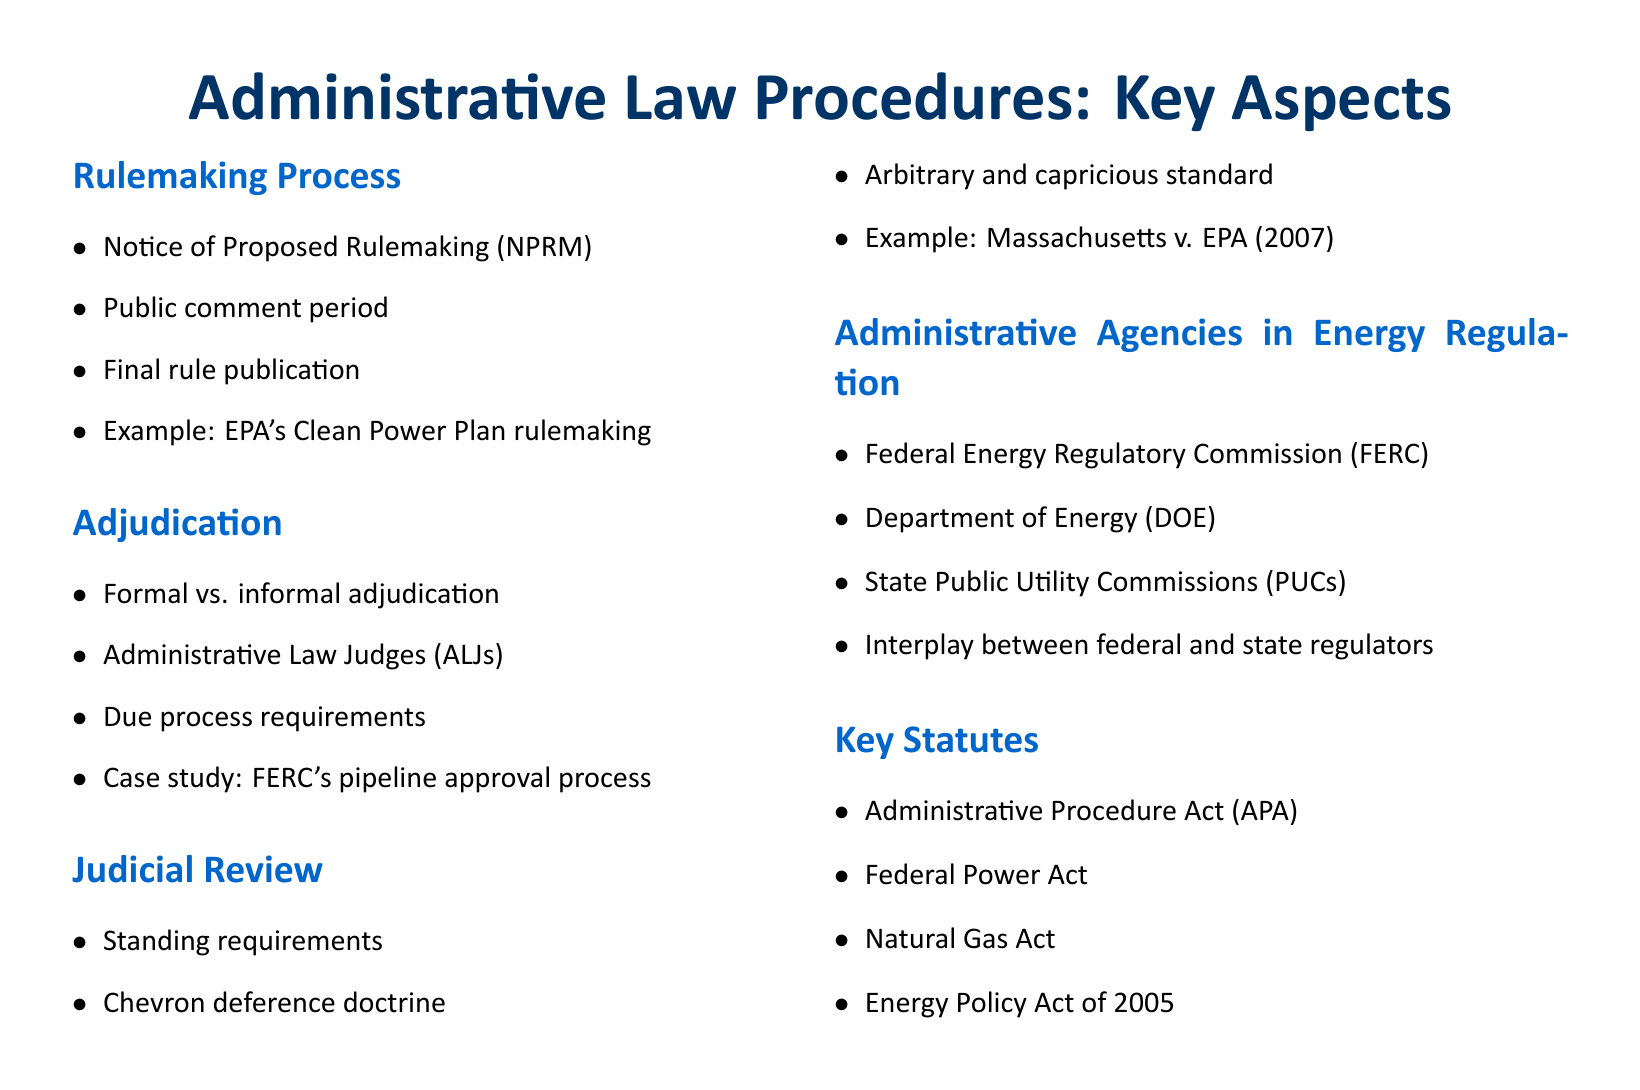What is the first step in the rulemaking process? The first step in the rulemaking process is the Notice of Proposed Rulemaking (NPRM), which is listed in the document under the section "Rulemaking Process."
Answer: Notice of Proposed Rulemaking (NPRM) Who is responsible for the formal adjudication process? Administrative Law Judges (ALJs) are responsible for the formal adjudication process, as mentioned in the "Adjudication" section.
Answer: Administrative Law Judges (ALJs) What case is used as an example in the judicial review section? The example provided in the judicial review section is Massachusetts v. EPA (2007), which is cited directly under the "Judicial Review" heading.
Answer: Massachusetts v. EPA (2007) How many key statutes are listed in the document? There are four key statutes listed in the "Key Statutes" section of the document.
Answer: Four What regulatory body is mentioned alongside the Department of Energy in energy regulation? The Federal Energy Regulatory Commission (FERC) is mentioned alongside the Department of Energy (DOE) in the "Administrative Agencies in Energy Regulation" section.
Answer: Federal Energy Regulatory Commission (FERC) What is the key principle established by the Chevron deference doctrine? The Chevron deference doctrine establishes a principle regarding judicial review of administrative actions, specifically related to agency interpretations of statutes.
Answer: Judicial review of administrative actions 